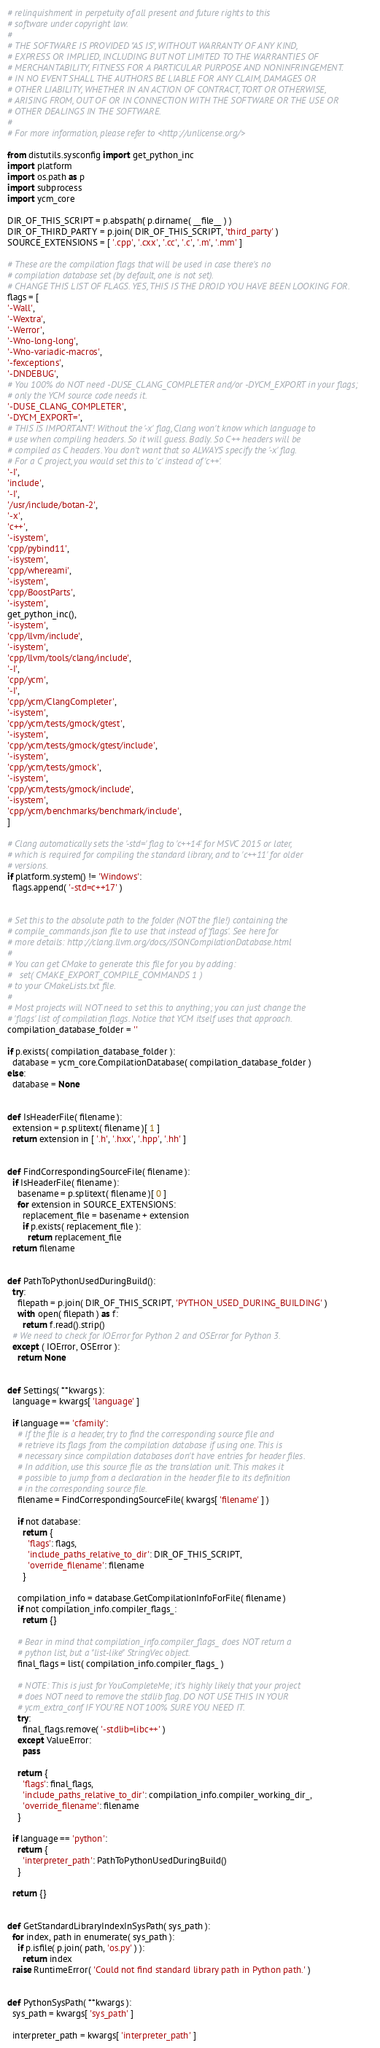<code> <loc_0><loc_0><loc_500><loc_500><_Python_># relinquishment in perpetuity of all present and future rights to this
# software under copyright law.
#
# THE SOFTWARE IS PROVIDED "AS IS", WITHOUT WARRANTY OF ANY KIND,
# EXPRESS OR IMPLIED, INCLUDING BUT NOT LIMITED TO THE WARRANTIES OF
# MERCHANTABILITY, FITNESS FOR A PARTICULAR PURPOSE AND NONINFRINGEMENT.
# IN NO EVENT SHALL THE AUTHORS BE LIABLE FOR ANY CLAIM, DAMAGES OR
# OTHER LIABILITY, WHETHER IN AN ACTION OF CONTRACT, TORT OR OTHERWISE,
# ARISING FROM, OUT OF OR IN CONNECTION WITH THE SOFTWARE OR THE USE OR
# OTHER DEALINGS IN THE SOFTWARE.
#
# For more information, please refer to <http://unlicense.org/>

from distutils.sysconfig import get_python_inc
import platform
import os.path as p
import subprocess
import ycm_core

DIR_OF_THIS_SCRIPT = p.abspath( p.dirname( __file__ ) )
DIR_OF_THIRD_PARTY = p.join( DIR_OF_THIS_SCRIPT, 'third_party' )
SOURCE_EXTENSIONS = [ '.cpp', '.cxx', '.cc', '.c', '.m', '.mm' ]

# These are the compilation flags that will be used in case there's no
# compilation database set (by default, one is not set).
# CHANGE THIS LIST OF FLAGS. YES, THIS IS THE DROID YOU HAVE BEEN LOOKING FOR.
flags = [
'-Wall',
'-Wextra',
'-Werror',
'-Wno-long-long',
'-Wno-variadic-macros',
'-fexceptions',
'-DNDEBUG',
# You 100% do NOT need -DUSE_CLANG_COMPLETER and/or -DYCM_EXPORT in your flags;
# only the YCM source code needs it.
'-DUSE_CLANG_COMPLETER',
'-DYCM_EXPORT=',
# THIS IS IMPORTANT! Without the '-x' flag, Clang won't know which language to
# use when compiling headers. So it will guess. Badly. So C++ headers will be
# compiled as C headers. You don't want that so ALWAYS specify the '-x' flag.
# For a C project, you would set this to 'c' instead of 'c++'.
'-I',
'include',
'-I',
'/usr/include/botan-2',
'-x',
'c++',
'-isystem',
'cpp/pybind11',
'-isystem',
'cpp/whereami',
'-isystem',
'cpp/BoostParts',
'-isystem',
get_python_inc(),
'-isystem',
'cpp/llvm/include',
'-isystem',
'cpp/llvm/tools/clang/include',
'-I',
'cpp/ycm',
'-I',
'cpp/ycm/ClangCompleter',
'-isystem',
'cpp/ycm/tests/gmock/gtest',
'-isystem',
'cpp/ycm/tests/gmock/gtest/include',
'-isystem',
'cpp/ycm/tests/gmock',
'-isystem',
'cpp/ycm/tests/gmock/include',
'-isystem',
'cpp/ycm/benchmarks/benchmark/include',
]

# Clang automatically sets the '-std=' flag to 'c++14' for MSVC 2015 or later,
# which is required for compiling the standard library, and to 'c++11' for older
# versions.
if platform.system() != 'Windows':
  flags.append( '-std=c++17' )


# Set this to the absolute path to the folder (NOT the file!) containing the
# compile_commands.json file to use that instead of 'flags'. See here for
# more details: http://clang.llvm.org/docs/JSONCompilationDatabase.html
#
# You can get CMake to generate this file for you by adding:
#   set( CMAKE_EXPORT_COMPILE_COMMANDS 1 )
# to your CMakeLists.txt file.
#
# Most projects will NOT need to set this to anything; you can just change the
# 'flags' list of compilation flags. Notice that YCM itself uses that approach.
compilation_database_folder = ''

if p.exists( compilation_database_folder ):
  database = ycm_core.CompilationDatabase( compilation_database_folder )
else:
  database = None


def IsHeaderFile( filename ):
  extension = p.splitext( filename )[ 1 ]
  return extension in [ '.h', '.hxx', '.hpp', '.hh' ]


def FindCorrespondingSourceFile( filename ):
  if IsHeaderFile( filename ):
    basename = p.splitext( filename )[ 0 ]
    for extension in SOURCE_EXTENSIONS:
      replacement_file = basename + extension
      if p.exists( replacement_file ):
        return replacement_file
  return filename


def PathToPythonUsedDuringBuild():
  try:
    filepath = p.join( DIR_OF_THIS_SCRIPT, 'PYTHON_USED_DURING_BUILDING' )
    with open( filepath ) as f:
      return f.read().strip()
  # We need to check for IOError for Python 2 and OSError for Python 3.
  except ( IOError, OSError ):
    return None


def Settings( **kwargs ):
  language = kwargs[ 'language' ]

  if language == 'cfamily':
    # If the file is a header, try to find the corresponding source file and
    # retrieve its flags from the compilation database if using one. This is
    # necessary since compilation databases don't have entries for header files.
    # In addition, use this source file as the translation unit. This makes it
    # possible to jump from a declaration in the header file to its definition
    # in the corresponding source file.
    filename = FindCorrespondingSourceFile( kwargs[ 'filename' ] )

    if not database:
      return {
        'flags': flags,
        'include_paths_relative_to_dir': DIR_OF_THIS_SCRIPT,
        'override_filename': filename
      }

    compilation_info = database.GetCompilationInfoForFile( filename )
    if not compilation_info.compiler_flags_:
      return {}

    # Bear in mind that compilation_info.compiler_flags_ does NOT return a
    # python list, but a "list-like" StringVec object.
    final_flags = list( compilation_info.compiler_flags_ )

    # NOTE: This is just for YouCompleteMe; it's highly likely that your project
    # does NOT need to remove the stdlib flag. DO NOT USE THIS IN YOUR
    # ycm_extra_conf IF YOU'RE NOT 100% SURE YOU NEED IT.
    try:
      final_flags.remove( '-stdlib=libc++' )
    except ValueError:
      pass

    return {
      'flags': final_flags,
      'include_paths_relative_to_dir': compilation_info.compiler_working_dir_,
      'override_filename': filename
    }

  if language == 'python':
    return {
      'interpreter_path': PathToPythonUsedDuringBuild()
    }

  return {}


def GetStandardLibraryIndexInSysPath( sys_path ):
  for index, path in enumerate( sys_path ):
    if p.isfile( p.join( path, 'os.py' ) ):
      return index
  raise RuntimeError( 'Could not find standard library path in Python path.' )


def PythonSysPath( **kwargs ):
  sys_path = kwargs[ 'sys_path' ]

  interpreter_path = kwargs[ 'interpreter_path' ]</code> 